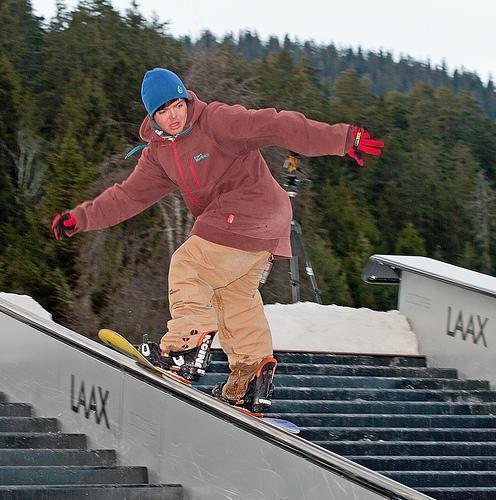How many men are there?
Give a very brief answer. 1. 